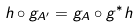<formula> <loc_0><loc_0><loc_500><loc_500>h \circ g _ { A ^ { \prime } } = g _ { A } \circ g ^ { * } h</formula> 